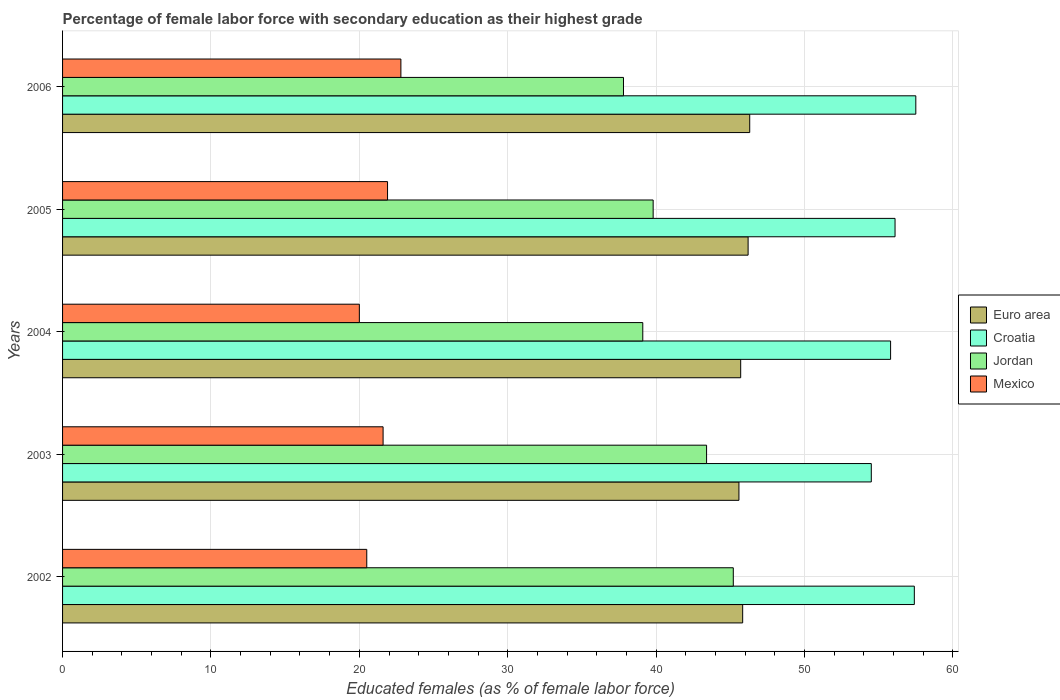How many different coloured bars are there?
Keep it short and to the point. 4. How many groups of bars are there?
Offer a very short reply. 5. Are the number of bars per tick equal to the number of legend labels?
Give a very brief answer. Yes. Are the number of bars on each tick of the Y-axis equal?
Give a very brief answer. Yes. How many bars are there on the 4th tick from the top?
Offer a terse response. 4. How many bars are there on the 1st tick from the bottom?
Provide a short and direct response. 4. What is the label of the 3rd group of bars from the top?
Ensure brevity in your answer.  2004. What is the percentage of female labor force with secondary education in Mexico in 2004?
Make the answer very short. 20. Across all years, what is the maximum percentage of female labor force with secondary education in Croatia?
Offer a terse response. 57.5. In which year was the percentage of female labor force with secondary education in Jordan maximum?
Ensure brevity in your answer.  2002. In which year was the percentage of female labor force with secondary education in Jordan minimum?
Ensure brevity in your answer.  2006. What is the total percentage of female labor force with secondary education in Mexico in the graph?
Give a very brief answer. 106.8. What is the difference between the percentage of female labor force with secondary education in Jordan in 2002 and that in 2003?
Provide a short and direct response. 1.8. What is the difference between the percentage of female labor force with secondary education in Euro area in 2004 and the percentage of female labor force with secondary education in Mexico in 2006?
Offer a very short reply. 22.9. What is the average percentage of female labor force with secondary education in Euro area per year?
Provide a succinct answer. 45.92. In the year 2005, what is the difference between the percentage of female labor force with secondary education in Mexico and percentage of female labor force with secondary education in Croatia?
Give a very brief answer. -34.2. In how many years, is the percentage of female labor force with secondary education in Mexico greater than 38 %?
Offer a very short reply. 0. What is the ratio of the percentage of female labor force with secondary education in Jordan in 2003 to that in 2005?
Offer a terse response. 1.09. Is the percentage of female labor force with secondary education in Mexico in 2002 less than that in 2005?
Ensure brevity in your answer.  Yes. Is the difference between the percentage of female labor force with secondary education in Mexico in 2002 and 2003 greater than the difference between the percentage of female labor force with secondary education in Croatia in 2002 and 2003?
Provide a short and direct response. No. What is the difference between the highest and the second highest percentage of female labor force with secondary education in Mexico?
Keep it short and to the point. 0.9. What is the difference between the highest and the lowest percentage of female labor force with secondary education in Euro area?
Offer a terse response. 0.73. In how many years, is the percentage of female labor force with secondary education in Euro area greater than the average percentage of female labor force with secondary education in Euro area taken over all years?
Your answer should be compact. 2. Is the sum of the percentage of female labor force with secondary education in Croatia in 2004 and 2006 greater than the maximum percentage of female labor force with secondary education in Euro area across all years?
Offer a very short reply. Yes. What does the 4th bar from the top in 2003 represents?
Your answer should be very brief. Euro area. Is it the case that in every year, the sum of the percentage of female labor force with secondary education in Jordan and percentage of female labor force with secondary education in Croatia is greater than the percentage of female labor force with secondary education in Mexico?
Keep it short and to the point. Yes. How many bars are there?
Make the answer very short. 20. Does the graph contain any zero values?
Give a very brief answer. No. Does the graph contain grids?
Provide a short and direct response. Yes. How many legend labels are there?
Provide a succinct answer. 4. How are the legend labels stacked?
Provide a short and direct response. Vertical. What is the title of the graph?
Offer a terse response. Percentage of female labor force with secondary education as their highest grade. Does "Congo (Democratic)" appear as one of the legend labels in the graph?
Keep it short and to the point. No. What is the label or title of the X-axis?
Offer a terse response. Educated females (as % of female labor force). What is the Educated females (as % of female labor force) of Euro area in 2002?
Make the answer very short. 45.83. What is the Educated females (as % of female labor force) in Croatia in 2002?
Provide a short and direct response. 57.4. What is the Educated females (as % of female labor force) of Jordan in 2002?
Offer a terse response. 45.2. What is the Educated females (as % of female labor force) of Mexico in 2002?
Your answer should be compact. 20.5. What is the Educated females (as % of female labor force) of Euro area in 2003?
Your answer should be very brief. 45.58. What is the Educated females (as % of female labor force) in Croatia in 2003?
Provide a short and direct response. 54.5. What is the Educated females (as % of female labor force) in Jordan in 2003?
Give a very brief answer. 43.4. What is the Educated females (as % of female labor force) in Mexico in 2003?
Keep it short and to the point. 21.6. What is the Educated females (as % of female labor force) of Euro area in 2004?
Make the answer very short. 45.7. What is the Educated females (as % of female labor force) in Croatia in 2004?
Your answer should be compact. 55.8. What is the Educated females (as % of female labor force) of Jordan in 2004?
Keep it short and to the point. 39.1. What is the Educated females (as % of female labor force) of Euro area in 2005?
Ensure brevity in your answer.  46.2. What is the Educated females (as % of female labor force) of Croatia in 2005?
Ensure brevity in your answer.  56.1. What is the Educated females (as % of female labor force) of Jordan in 2005?
Make the answer very short. 39.8. What is the Educated females (as % of female labor force) of Mexico in 2005?
Your answer should be very brief. 21.9. What is the Educated females (as % of female labor force) in Euro area in 2006?
Provide a short and direct response. 46.31. What is the Educated females (as % of female labor force) of Croatia in 2006?
Make the answer very short. 57.5. What is the Educated females (as % of female labor force) of Jordan in 2006?
Make the answer very short. 37.8. What is the Educated females (as % of female labor force) in Mexico in 2006?
Ensure brevity in your answer.  22.8. Across all years, what is the maximum Educated females (as % of female labor force) of Euro area?
Provide a short and direct response. 46.31. Across all years, what is the maximum Educated females (as % of female labor force) of Croatia?
Your response must be concise. 57.5. Across all years, what is the maximum Educated females (as % of female labor force) in Jordan?
Offer a terse response. 45.2. Across all years, what is the maximum Educated females (as % of female labor force) in Mexico?
Keep it short and to the point. 22.8. Across all years, what is the minimum Educated females (as % of female labor force) of Euro area?
Your answer should be very brief. 45.58. Across all years, what is the minimum Educated females (as % of female labor force) of Croatia?
Your answer should be very brief. 54.5. Across all years, what is the minimum Educated females (as % of female labor force) in Jordan?
Ensure brevity in your answer.  37.8. What is the total Educated females (as % of female labor force) of Euro area in the graph?
Offer a very short reply. 229.62. What is the total Educated females (as % of female labor force) in Croatia in the graph?
Offer a very short reply. 281.3. What is the total Educated females (as % of female labor force) in Jordan in the graph?
Make the answer very short. 205.3. What is the total Educated females (as % of female labor force) in Mexico in the graph?
Make the answer very short. 106.8. What is the difference between the Educated females (as % of female labor force) in Euro area in 2002 and that in 2003?
Your answer should be very brief. 0.25. What is the difference between the Educated females (as % of female labor force) of Croatia in 2002 and that in 2003?
Offer a terse response. 2.9. What is the difference between the Educated females (as % of female labor force) of Jordan in 2002 and that in 2003?
Your answer should be very brief. 1.8. What is the difference between the Educated females (as % of female labor force) in Euro area in 2002 and that in 2004?
Your response must be concise. 0.13. What is the difference between the Educated females (as % of female labor force) in Croatia in 2002 and that in 2004?
Make the answer very short. 1.6. What is the difference between the Educated females (as % of female labor force) of Euro area in 2002 and that in 2005?
Your answer should be compact. -0.37. What is the difference between the Educated females (as % of female labor force) in Croatia in 2002 and that in 2005?
Your answer should be compact. 1.3. What is the difference between the Educated females (as % of female labor force) of Jordan in 2002 and that in 2005?
Provide a short and direct response. 5.4. What is the difference between the Educated females (as % of female labor force) of Euro area in 2002 and that in 2006?
Offer a terse response. -0.48. What is the difference between the Educated females (as % of female labor force) in Croatia in 2002 and that in 2006?
Your answer should be very brief. -0.1. What is the difference between the Educated females (as % of female labor force) of Jordan in 2002 and that in 2006?
Provide a succinct answer. 7.4. What is the difference between the Educated females (as % of female labor force) in Mexico in 2002 and that in 2006?
Your response must be concise. -2.3. What is the difference between the Educated females (as % of female labor force) in Euro area in 2003 and that in 2004?
Provide a succinct answer. -0.12. What is the difference between the Educated females (as % of female labor force) in Euro area in 2003 and that in 2005?
Your answer should be very brief. -0.62. What is the difference between the Educated females (as % of female labor force) of Mexico in 2003 and that in 2005?
Your answer should be very brief. -0.3. What is the difference between the Educated females (as % of female labor force) of Euro area in 2003 and that in 2006?
Provide a succinct answer. -0.73. What is the difference between the Educated females (as % of female labor force) in Croatia in 2003 and that in 2006?
Offer a terse response. -3. What is the difference between the Educated females (as % of female labor force) in Jordan in 2003 and that in 2006?
Keep it short and to the point. 5.6. What is the difference between the Educated females (as % of female labor force) of Euro area in 2004 and that in 2005?
Ensure brevity in your answer.  -0.5. What is the difference between the Educated females (as % of female labor force) in Croatia in 2004 and that in 2005?
Your answer should be very brief. -0.3. What is the difference between the Educated females (as % of female labor force) in Mexico in 2004 and that in 2005?
Your answer should be compact. -1.9. What is the difference between the Educated females (as % of female labor force) in Euro area in 2004 and that in 2006?
Your answer should be very brief. -0.61. What is the difference between the Educated females (as % of female labor force) of Jordan in 2004 and that in 2006?
Provide a succinct answer. 1.3. What is the difference between the Educated females (as % of female labor force) of Mexico in 2004 and that in 2006?
Keep it short and to the point. -2.8. What is the difference between the Educated females (as % of female labor force) in Euro area in 2005 and that in 2006?
Your response must be concise. -0.11. What is the difference between the Educated females (as % of female labor force) in Croatia in 2005 and that in 2006?
Keep it short and to the point. -1.4. What is the difference between the Educated females (as % of female labor force) in Euro area in 2002 and the Educated females (as % of female labor force) in Croatia in 2003?
Give a very brief answer. -8.67. What is the difference between the Educated females (as % of female labor force) in Euro area in 2002 and the Educated females (as % of female labor force) in Jordan in 2003?
Your answer should be very brief. 2.43. What is the difference between the Educated females (as % of female labor force) in Euro area in 2002 and the Educated females (as % of female labor force) in Mexico in 2003?
Keep it short and to the point. 24.23. What is the difference between the Educated females (as % of female labor force) of Croatia in 2002 and the Educated females (as % of female labor force) of Jordan in 2003?
Ensure brevity in your answer.  14. What is the difference between the Educated females (as % of female labor force) in Croatia in 2002 and the Educated females (as % of female labor force) in Mexico in 2003?
Keep it short and to the point. 35.8. What is the difference between the Educated females (as % of female labor force) in Jordan in 2002 and the Educated females (as % of female labor force) in Mexico in 2003?
Provide a short and direct response. 23.6. What is the difference between the Educated females (as % of female labor force) in Euro area in 2002 and the Educated females (as % of female labor force) in Croatia in 2004?
Provide a short and direct response. -9.97. What is the difference between the Educated females (as % of female labor force) of Euro area in 2002 and the Educated females (as % of female labor force) of Jordan in 2004?
Your response must be concise. 6.73. What is the difference between the Educated females (as % of female labor force) in Euro area in 2002 and the Educated females (as % of female labor force) in Mexico in 2004?
Offer a very short reply. 25.83. What is the difference between the Educated females (as % of female labor force) of Croatia in 2002 and the Educated females (as % of female labor force) of Mexico in 2004?
Provide a short and direct response. 37.4. What is the difference between the Educated females (as % of female labor force) in Jordan in 2002 and the Educated females (as % of female labor force) in Mexico in 2004?
Provide a short and direct response. 25.2. What is the difference between the Educated females (as % of female labor force) of Euro area in 2002 and the Educated females (as % of female labor force) of Croatia in 2005?
Give a very brief answer. -10.27. What is the difference between the Educated females (as % of female labor force) of Euro area in 2002 and the Educated females (as % of female labor force) of Jordan in 2005?
Make the answer very short. 6.03. What is the difference between the Educated females (as % of female labor force) of Euro area in 2002 and the Educated females (as % of female labor force) of Mexico in 2005?
Ensure brevity in your answer.  23.93. What is the difference between the Educated females (as % of female labor force) in Croatia in 2002 and the Educated females (as % of female labor force) in Jordan in 2005?
Your response must be concise. 17.6. What is the difference between the Educated females (as % of female labor force) in Croatia in 2002 and the Educated females (as % of female labor force) in Mexico in 2005?
Keep it short and to the point. 35.5. What is the difference between the Educated females (as % of female labor force) of Jordan in 2002 and the Educated females (as % of female labor force) of Mexico in 2005?
Offer a terse response. 23.3. What is the difference between the Educated females (as % of female labor force) in Euro area in 2002 and the Educated females (as % of female labor force) in Croatia in 2006?
Provide a short and direct response. -11.67. What is the difference between the Educated females (as % of female labor force) of Euro area in 2002 and the Educated females (as % of female labor force) of Jordan in 2006?
Offer a terse response. 8.03. What is the difference between the Educated females (as % of female labor force) in Euro area in 2002 and the Educated females (as % of female labor force) in Mexico in 2006?
Provide a succinct answer. 23.03. What is the difference between the Educated females (as % of female labor force) of Croatia in 2002 and the Educated females (as % of female labor force) of Jordan in 2006?
Provide a short and direct response. 19.6. What is the difference between the Educated females (as % of female labor force) of Croatia in 2002 and the Educated females (as % of female labor force) of Mexico in 2006?
Provide a succinct answer. 34.6. What is the difference between the Educated females (as % of female labor force) in Jordan in 2002 and the Educated females (as % of female labor force) in Mexico in 2006?
Provide a succinct answer. 22.4. What is the difference between the Educated females (as % of female labor force) of Euro area in 2003 and the Educated females (as % of female labor force) of Croatia in 2004?
Provide a succinct answer. -10.22. What is the difference between the Educated females (as % of female labor force) of Euro area in 2003 and the Educated females (as % of female labor force) of Jordan in 2004?
Make the answer very short. 6.48. What is the difference between the Educated females (as % of female labor force) of Euro area in 2003 and the Educated females (as % of female labor force) of Mexico in 2004?
Keep it short and to the point. 25.58. What is the difference between the Educated females (as % of female labor force) in Croatia in 2003 and the Educated females (as % of female labor force) in Jordan in 2004?
Your response must be concise. 15.4. What is the difference between the Educated females (as % of female labor force) of Croatia in 2003 and the Educated females (as % of female labor force) of Mexico in 2004?
Your response must be concise. 34.5. What is the difference between the Educated females (as % of female labor force) of Jordan in 2003 and the Educated females (as % of female labor force) of Mexico in 2004?
Offer a terse response. 23.4. What is the difference between the Educated females (as % of female labor force) in Euro area in 2003 and the Educated females (as % of female labor force) in Croatia in 2005?
Your answer should be compact. -10.52. What is the difference between the Educated females (as % of female labor force) of Euro area in 2003 and the Educated females (as % of female labor force) of Jordan in 2005?
Provide a succinct answer. 5.78. What is the difference between the Educated females (as % of female labor force) of Euro area in 2003 and the Educated females (as % of female labor force) of Mexico in 2005?
Provide a short and direct response. 23.68. What is the difference between the Educated females (as % of female labor force) of Croatia in 2003 and the Educated females (as % of female labor force) of Mexico in 2005?
Offer a terse response. 32.6. What is the difference between the Educated females (as % of female labor force) in Euro area in 2003 and the Educated females (as % of female labor force) in Croatia in 2006?
Offer a very short reply. -11.92. What is the difference between the Educated females (as % of female labor force) in Euro area in 2003 and the Educated females (as % of female labor force) in Jordan in 2006?
Offer a terse response. 7.78. What is the difference between the Educated females (as % of female labor force) in Euro area in 2003 and the Educated females (as % of female labor force) in Mexico in 2006?
Your response must be concise. 22.78. What is the difference between the Educated females (as % of female labor force) of Croatia in 2003 and the Educated females (as % of female labor force) of Mexico in 2006?
Give a very brief answer. 31.7. What is the difference between the Educated females (as % of female labor force) of Jordan in 2003 and the Educated females (as % of female labor force) of Mexico in 2006?
Your answer should be compact. 20.6. What is the difference between the Educated females (as % of female labor force) in Euro area in 2004 and the Educated females (as % of female labor force) in Croatia in 2005?
Your answer should be very brief. -10.4. What is the difference between the Educated females (as % of female labor force) in Euro area in 2004 and the Educated females (as % of female labor force) in Jordan in 2005?
Provide a short and direct response. 5.9. What is the difference between the Educated females (as % of female labor force) of Euro area in 2004 and the Educated females (as % of female labor force) of Mexico in 2005?
Your answer should be compact. 23.8. What is the difference between the Educated females (as % of female labor force) in Croatia in 2004 and the Educated females (as % of female labor force) in Mexico in 2005?
Make the answer very short. 33.9. What is the difference between the Educated females (as % of female labor force) in Euro area in 2004 and the Educated females (as % of female labor force) in Croatia in 2006?
Offer a terse response. -11.8. What is the difference between the Educated females (as % of female labor force) of Euro area in 2004 and the Educated females (as % of female labor force) of Jordan in 2006?
Your answer should be compact. 7.9. What is the difference between the Educated females (as % of female labor force) in Euro area in 2004 and the Educated females (as % of female labor force) in Mexico in 2006?
Your answer should be very brief. 22.9. What is the difference between the Educated females (as % of female labor force) of Croatia in 2004 and the Educated females (as % of female labor force) of Mexico in 2006?
Offer a terse response. 33. What is the difference between the Educated females (as % of female labor force) of Euro area in 2005 and the Educated females (as % of female labor force) of Croatia in 2006?
Make the answer very short. -11.3. What is the difference between the Educated females (as % of female labor force) in Euro area in 2005 and the Educated females (as % of female labor force) in Jordan in 2006?
Offer a very short reply. 8.4. What is the difference between the Educated females (as % of female labor force) of Euro area in 2005 and the Educated females (as % of female labor force) of Mexico in 2006?
Keep it short and to the point. 23.4. What is the difference between the Educated females (as % of female labor force) of Croatia in 2005 and the Educated females (as % of female labor force) of Mexico in 2006?
Offer a terse response. 33.3. What is the average Educated females (as % of female labor force) in Euro area per year?
Your response must be concise. 45.92. What is the average Educated females (as % of female labor force) in Croatia per year?
Provide a succinct answer. 56.26. What is the average Educated females (as % of female labor force) in Jordan per year?
Your response must be concise. 41.06. What is the average Educated females (as % of female labor force) in Mexico per year?
Your answer should be very brief. 21.36. In the year 2002, what is the difference between the Educated females (as % of female labor force) of Euro area and Educated females (as % of female labor force) of Croatia?
Offer a terse response. -11.57. In the year 2002, what is the difference between the Educated females (as % of female labor force) of Euro area and Educated females (as % of female labor force) of Jordan?
Your response must be concise. 0.63. In the year 2002, what is the difference between the Educated females (as % of female labor force) of Euro area and Educated females (as % of female labor force) of Mexico?
Your answer should be very brief. 25.33. In the year 2002, what is the difference between the Educated females (as % of female labor force) in Croatia and Educated females (as % of female labor force) in Mexico?
Provide a short and direct response. 36.9. In the year 2002, what is the difference between the Educated females (as % of female labor force) in Jordan and Educated females (as % of female labor force) in Mexico?
Offer a terse response. 24.7. In the year 2003, what is the difference between the Educated females (as % of female labor force) in Euro area and Educated females (as % of female labor force) in Croatia?
Your answer should be compact. -8.92. In the year 2003, what is the difference between the Educated females (as % of female labor force) in Euro area and Educated females (as % of female labor force) in Jordan?
Your answer should be compact. 2.18. In the year 2003, what is the difference between the Educated females (as % of female labor force) of Euro area and Educated females (as % of female labor force) of Mexico?
Give a very brief answer. 23.98. In the year 2003, what is the difference between the Educated females (as % of female labor force) in Croatia and Educated females (as % of female labor force) in Jordan?
Give a very brief answer. 11.1. In the year 2003, what is the difference between the Educated females (as % of female labor force) in Croatia and Educated females (as % of female labor force) in Mexico?
Make the answer very short. 32.9. In the year 2003, what is the difference between the Educated females (as % of female labor force) in Jordan and Educated females (as % of female labor force) in Mexico?
Provide a succinct answer. 21.8. In the year 2004, what is the difference between the Educated females (as % of female labor force) of Euro area and Educated females (as % of female labor force) of Croatia?
Ensure brevity in your answer.  -10.1. In the year 2004, what is the difference between the Educated females (as % of female labor force) in Euro area and Educated females (as % of female labor force) in Jordan?
Keep it short and to the point. 6.6. In the year 2004, what is the difference between the Educated females (as % of female labor force) of Euro area and Educated females (as % of female labor force) of Mexico?
Provide a succinct answer. 25.7. In the year 2004, what is the difference between the Educated females (as % of female labor force) of Croatia and Educated females (as % of female labor force) of Jordan?
Keep it short and to the point. 16.7. In the year 2004, what is the difference between the Educated females (as % of female labor force) in Croatia and Educated females (as % of female labor force) in Mexico?
Provide a short and direct response. 35.8. In the year 2004, what is the difference between the Educated females (as % of female labor force) of Jordan and Educated females (as % of female labor force) of Mexico?
Ensure brevity in your answer.  19.1. In the year 2005, what is the difference between the Educated females (as % of female labor force) of Euro area and Educated females (as % of female labor force) of Croatia?
Ensure brevity in your answer.  -9.9. In the year 2005, what is the difference between the Educated females (as % of female labor force) of Euro area and Educated females (as % of female labor force) of Jordan?
Your answer should be compact. 6.4. In the year 2005, what is the difference between the Educated females (as % of female labor force) in Euro area and Educated females (as % of female labor force) in Mexico?
Keep it short and to the point. 24.3. In the year 2005, what is the difference between the Educated females (as % of female labor force) of Croatia and Educated females (as % of female labor force) of Mexico?
Give a very brief answer. 34.2. In the year 2005, what is the difference between the Educated females (as % of female labor force) in Jordan and Educated females (as % of female labor force) in Mexico?
Offer a terse response. 17.9. In the year 2006, what is the difference between the Educated females (as % of female labor force) in Euro area and Educated females (as % of female labor force) in Croatia?
Offer a terse response. -11.19. In the year 2006, what is the difference between the Educated females (as % of female labor force) of Euro area and Educated females (as % of female labor force) of Jordan?
Make the answer very short. 8.51. In the year 2006, what is the difference between the Educated females (as % of female labor force) of Euro area and Educated females (as % of female labor force) of Mexico?
Offer a very short reply. 23.51. In the year 2006, what is the difference between the Educated females (as % of female labor force) in Croatia and Educated females (as % of female labor force) in Mexico?
Offer a terse response. 34.7. In the year 2006, what is the difference between the Educated females (as % of female labor force) in Jordan and Educated females (as % of female labor force) in Mexico?
Offer a terse response. 15. What is the ratio of the Educated females (as % of female labor force) of Euro area in 2002 to that in 2003?
Your answer should be very brief. 1.01. What is the ratio of the Educated females (as % of female labor force) in Croatia in 2002 to that in 2003?
Your answer should be very brief. 1.05. What is the ratio of the Educated females (as % of female labor force) of Jordan in 2002 to that in 2003?
Provide a succinct answer. 1.04. What is the ratio of the Educated females (as % of female labor force) of Mexico in 2002 to that in 2003?
Ensure brevity in your answer.  0.95. What is the ratio of the Educated females (as % of female labor force) of Euro area in 2002 to that in 2004?
Give a very brief answer. 1. What is the ratio of the Educated females (as % of female labor force) in Croatia in 2002 to that in 2004?
Keep it short and to the point. 1.03. What is the ratio of the Educated females (as % of female labor force) of Jordan in 2002 to that in 2004?
Give a very brief answer. 1.16. What is the ratio of the Educated females (as % of female labor force) in Mexico in 2002 to that in 2004?
Give a very brief answer. 1.02. What is the ratio of the Educated females (as % of female labor force) of Croatia in 2002 to that in 2005?
Your answer should be very brief. 1.02. What is the ratio of the Educated females (as % of female labor force) in Jordan in 2002 to that in 2005?
Provide a succinct answer. 1.14. What is the ratio of the Educated females (as % of female labor force) of Mexico in 2002 to that in 2005?
Your answer should be very brief. 0.94. What is the ratio of the Educated females (as % of female labor force) of Jordan in 2002 to that in 2006?
Provide a short and direct response. 1.2. What is the ratio of the Educated females (as % of female labor force) of Mexico in 2002 to that in 2006?
Offer a very short reply. 0.9. What is the ratio of the Educated females (as % of female labor force) in Croatia in 2003 to that in 2004?
Your response must be concise. 0.98. What is the ratio of the Educated females (as % of female labor force) in Jordan in 2003 to that in 2004?
Provide a short and direct response. 1.11. What is the ratio of the Educated females (as % of female labor force) in Euro area in 2003 to that in 2005?
Your response must be concise. 0.99. What is the ratio of the Educated females (as % of female labor force) of Croatia in 2003 to that in 2005?
Offer a terse response. 0.97. What is the ratio of the Educated females (as % of female labor force) in Jordan in 2003 to that in 2005?
Your response must be concise. 1.09. What is the ratio of the Educated females (as % of female labor force) in Mexico in 2003 to that in 2005?
Your response must be concise. 0.99. What is the ratio of the Educated females (as % of female labor force) of Euro area in 2003 to that in 2006?
Make the answer very short. 0.98. What is the ratio of the Educated females (as % of female labor force) of Croatia in 2003 to that in 2006?
Your answer should be compact. 0.95. What is the ratio of the Educated females (as % of female labor force) of Jordan in 2003 to that in 2006?
Keep it short and to the point. 1.15. What is the ratio of the Educated females (as % of female labor force) of Euro area in 2004 to that in 2005?
Keep it short and to the point. 0.99. What is the ratio of the Educated females (as % of female labor force) in Croatia in 2004 to that in 2005?
Offer a very short reply. 0.99. What is the ratio of the Educated females (as % of female labor force) in Jordan in 2004 to that in 2005?
Offer a terse response. 0.98. What is the ratio of the Educated females (as % of female labor force) in Mexico in 2004 to that in 2005?
Offer a terse response. 0.91. What is the ratio of the Educated females (as % of female labor force) in Euro area in 2004 to that in 2006?
Keep it short and to the point. 0.99. What is the ratio of the Educated females (as % of female labor force) of Croatia in 2004 to that in 2006?
Give a very brief answer. 0.97. What is the ratio of the Educated females (as % of female labor force) of Jordan in 2004 to that in 2006?
Your response must be concise. 1.03. What is the ratio of the Educated females (as % of female labor force) in Mexico in 2004 to that in 2006?
Your response must be concise. 0.88. What is the ratio of the Educated females (as % of female labor force) in Croatia in 2005 to that in 2006?
Provide a succinct answer. 0.98. What is the ratio of the Educated females (as % of female labor force) of Jordan in 2005 to that in 2006?
Make the answer very short. 1.05. What is the ratio of the Educated females (as % of female labor force) in Mexico in 2005 to that in 2006?
Make the answer very short. 0.96. What is the difference between the highest and the second highest Educated females (as % of female labor force) in Euro area?
Give a very brief answer. 0.11. What is the difference between the highest and the second highest Educated females (as % of female labor force) in Croatia?
Give a very brief answer. 0.1. What is the difference between the highest and the second highest Educated females (as % of female labor force) of Jordan?
Provide a succinct answer. 1.8. What is the difference between the highest and the second highest Educated females (as % of female labor force) in Mexico?
Offer a very short reply. 0.9. What is the difference between the highest and the lowest Educated females (as % of female labor force) of Euro area?
Make the answer very short. 0.73. What is the difference between the highest and the lowest Educated females (as % of female labor force) of Croatia?
Your answer should be very brief. 3. What is the difference between the highest and the lowest Educated females (as % of female labor force) in Jordan?
Make the answer very short. 7.4. What is the difference between the highest and the lowest Educated females (as % of female labor force) of Mexico?
Make the answer very short. 2.8. 